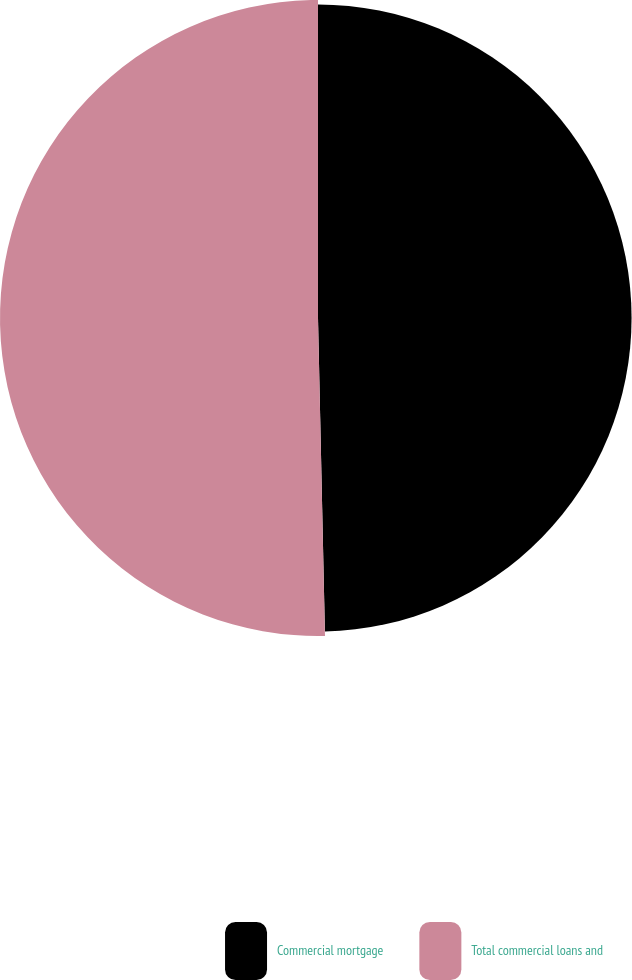Convert chart to OTSL. <chart><loc_0><loc_0><loc_500><loc_500><pie_chart><fcel>Commercial mortgage<fcel>Total commercial loans and<nl><fcel>49.65%<fcel>50.35%<nl></chart> 